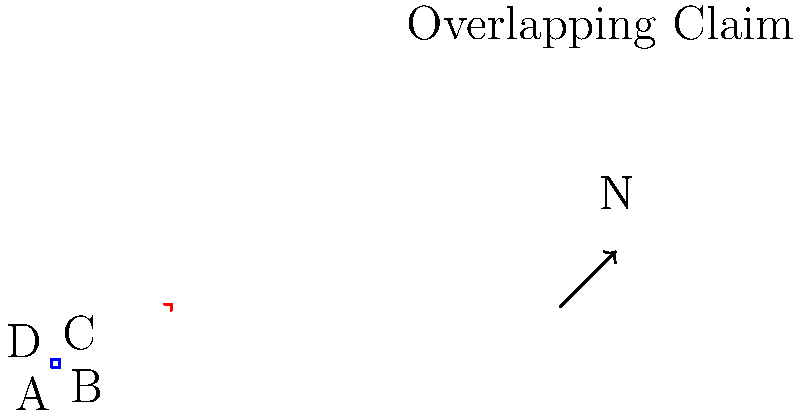In the property boundary map shown, there is an overlapping claim represented by the dashed red line. If the original property is defined by points A, B, C, and D, what is the most appropriate legal action to resolve this boundary dispute? To resolve this boundary dispute, we need to follow these steps:

1. Identify the nature of the dispute:
   - The solid blue line represents the original property boundary (ABCD).
   - The dashed red line indicates an overlapping claim.

2. Determine the extent of the overlap:
   - The overlap appears to affect a significant portion of the original property.

3. Consider legal options:
   a) Negotiate with the claimant:
      - This is often the first step to avoid costly litigation.
   b) Conduct a professional survey:
      - To accurately determine the true boundary lines.
   c) Review historical documents:
      - Examine deeds, plats, and other relevant records.
   d) Mediation:
      - A neutral third party can help facilitate an agreement.
   e) Quiet title action:
      - A legal proceeding to establish clear ownership.

4. Evaluate the strength of each party's claim:
   - Based on documentation, duration of possession, and other factors.

5. Consider adverse possession laws:
   - If the claimant has occupied the disputed area for a statutory period.

6. Assess the potential for easements or prescriptive rights:
   - If long-term use has established certain rights.

Given the significant overlap and the complexity of property law, the most appropriate initial action would be to attempt negotiation with the claimant, followed by a professional survey if negotiation fails. This approach allows for a potential amicable resolution while also gathering crucial evidence for potential legal proceedings.

If negotiation and survey do not resolve the issue, the next step would be to file a quiet title action to legally establish the boundary and ownership rights.
Answer: Negotiate, then survey; if unresolved, file quiet title action. 